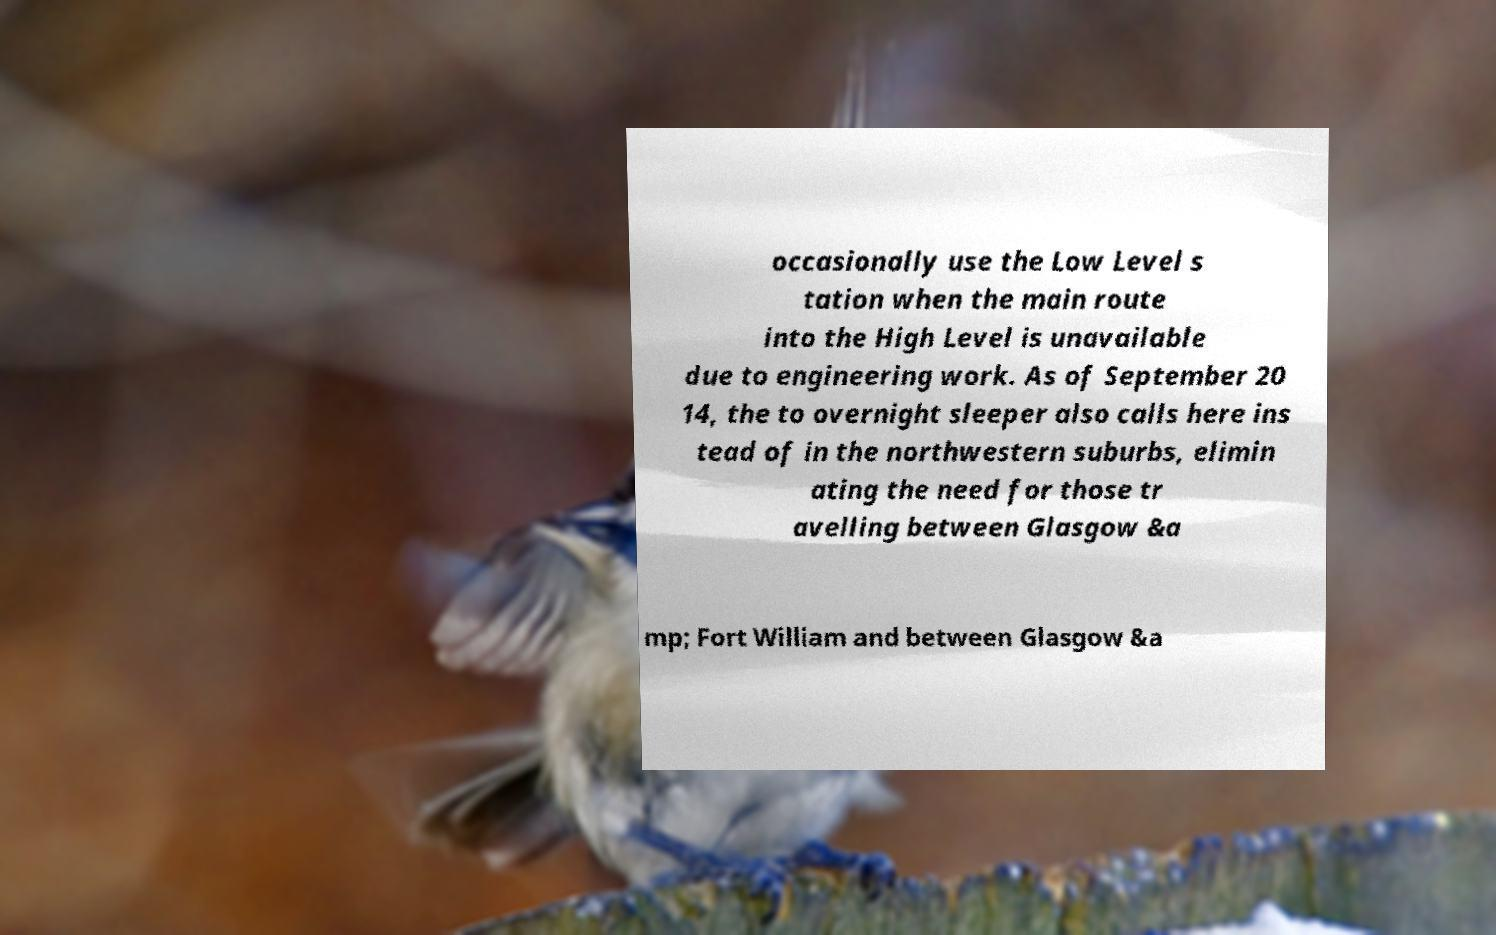There's text embedded in this image that I need extracted. Can you transcribe it verbatim? occasionally use the Low Level s tation when the main route into the High Level is unavailable due to engineering work. As of September 20 14, the to overnight sleeper also calls here ins tead of in the northwestern suburbs, elimin ating the need for those tr avelling between Glasgow &a mp; Fort William and between Glasgow &a 